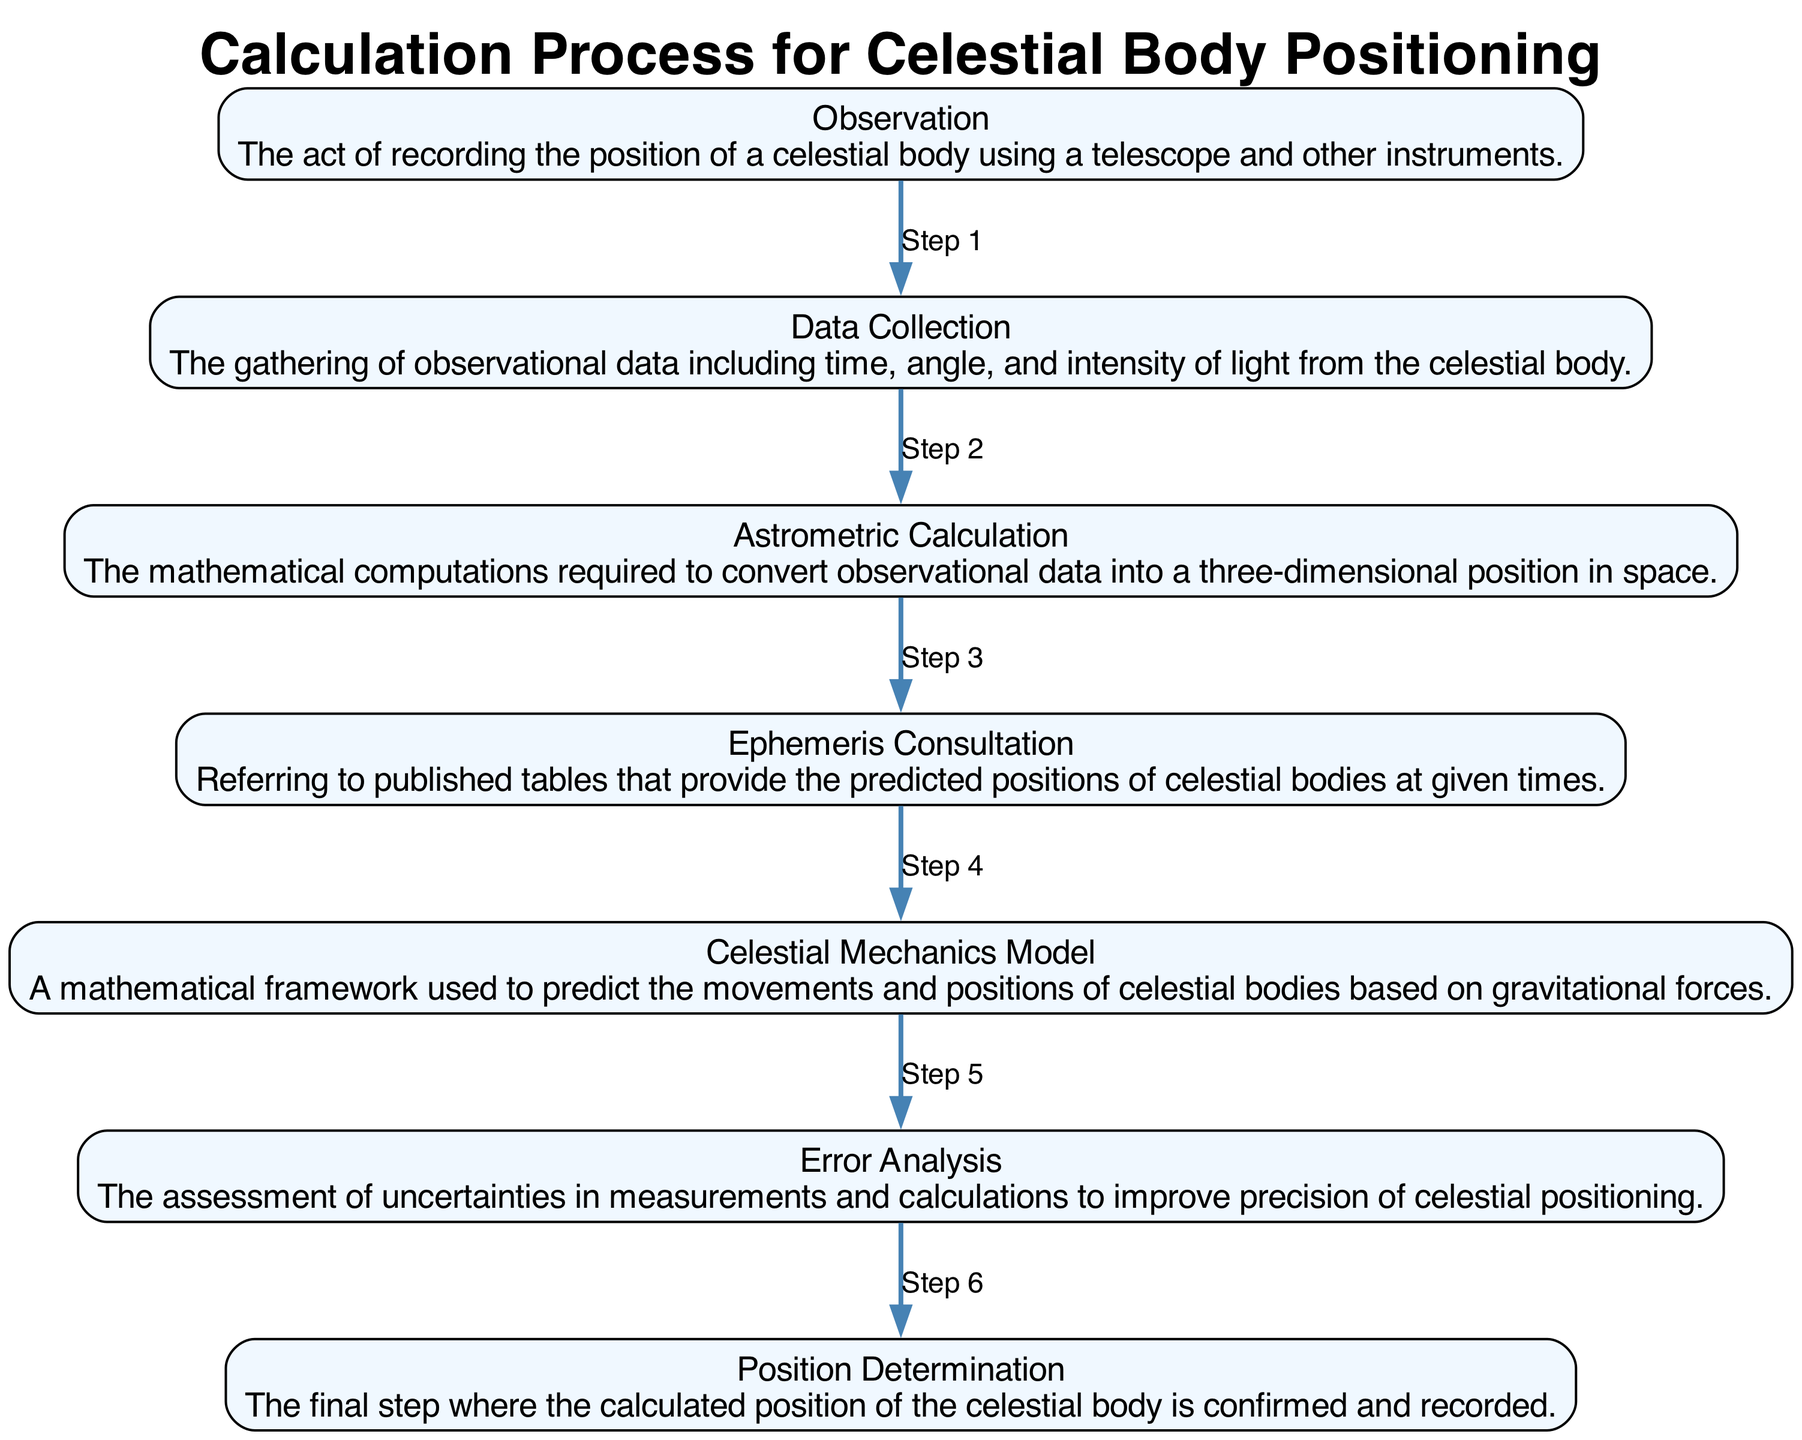What is the first step in the calculation process? The first step as depicted in the diagram is "Observation," which represents the act of recording the position of a celestial body.
Answer: Observation How many steps are involved in determining the position of a celestial body? By counting the nodes in the diagram, there are a total of seven steps included in the calculation process.
Answer: Seven What follows "Data Collection" in the process? The step that follows "Data Collection" is "Astrometric Calculation," where mathematical computations are made to derive the three-dimensional position.
Answer: Astrometric Calculation What is the last step of the calculation process? The final step in the process is "Position Determination," which confirms and records the calculated position of the celestial body.
Answer: Position Determination Which step involves the assessment of measurement uncertainties? The step that involves assessing uncertainties is "Error Analysis," where errors are evaluated to enhance the precision of celestial positioning.
Answer: Error Analysis What is the relationship between "Ephemeris Consultation" and "Astrometric Calculation"? "Ephemeris Consultation" occurs prior to "Astrometric Calculation," suggesting that predicted positions from consultation inform the subsequent calculations needed for precise positioning.
Answer: Ephemeris Consultation leads to Astrometric Calculation How is the step "Celestial Mechanics Model" related to the overall calculation process? The "Celestial Mechanics Model" is interrelated as it provides a mathematical framework essential for predicting movements and positions, forming the basis for further computations and analysis.
Answer: Provides predictive framework Which step(s) could potentially be influenced by "Error Analysis"? "Astrometric Calculation" and "Position Determination" could be influenced by "Error Analysis" since improving precision in these stages relies on evaluating uncertainties from previous steps.
Answer: Astrometric Calculation and Position Determination 